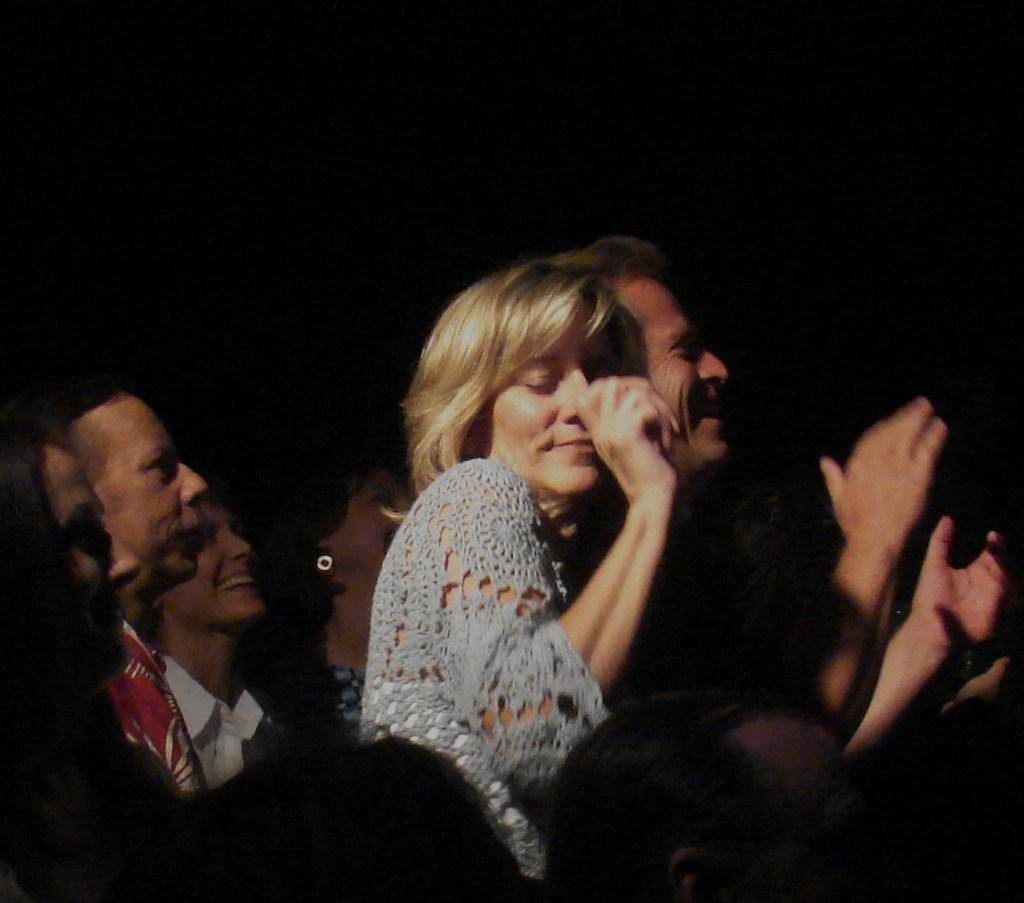How many people are in the image? There are people in the image, but the exact number is not specified. Where are the people located in the image? The people are standing in the center of the image. What is the emotional state of the people in the image? The people are smiling, as indicated by their facial expressions. What type of argument is taking place between the ladybug and the glass in the image? There is no ladybug or glass present in the image, so no such argument can be observed. 